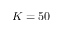Convert formula to latex. <formula><loc_0><loc_0><loc_500><loc_500>K = 5 0</formula> 